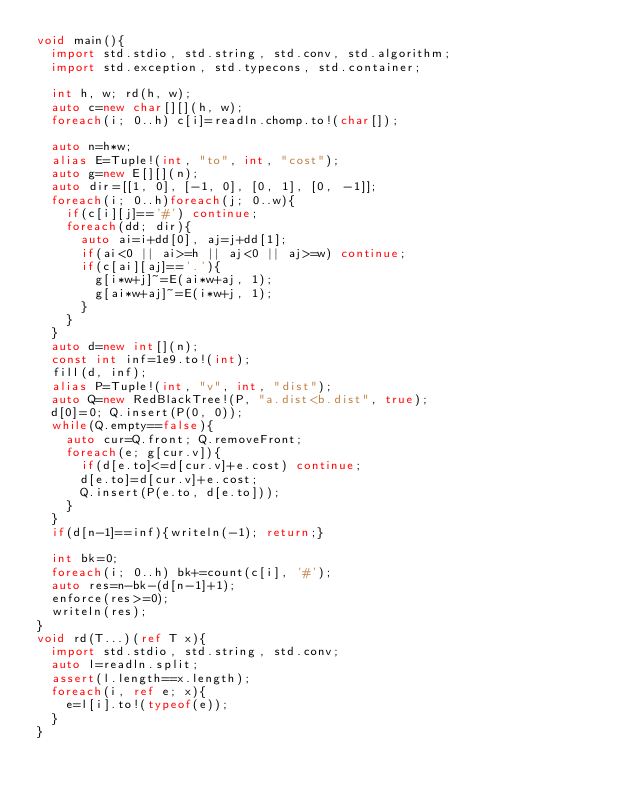Convert code to text. <code><loc_0><loc_0><loc_500><loc_500><_D_>void main(){
  import std.stdio, std.string, std.conv, std.algorithm;
  import std.exception, std.typecons, std.container;

  int h, w; rd(h, w);
  auto c=new char[][](h, w);
  foreach(i; 0..h) c[i]=readln.chomp.to!(char[]);

  auto n=h*w;
  alias E=Tuple!(int, "to", int, "cost");
  auto g=new E[][](n);
  auto dir=[[1, 0], [-1, 0], [0, 1], [0, -1]];
  foreach(i; 0..h)foreach(j; 0..w){
    if(c[i][j]=='#') continue;
    foreach(dd; dir){
      auto ai=i+dd[0], aj=j+dd[1];
      if(ai<0 || ai>=h || aj<0 || aj>=w) continue;
      if(c[ai][aj]=='.'){
        g[i*w+j]~=E(ai*w+aj, 1);
        g[ai*w+aj]~=E(i*w+j, 1);
      }
    }
  }
  auto d=new int[](n);
  const int inf=1e9.to!(int);
  fill(d, inf);
  alias P=Tuple!(int, "v", int, "dist");
  auto Q=new RedBlackTree!(P, "a.dist<b.dist", true);
  d[0]=0; Q.insert(P(0, 0));
  while(Q.empty==false){
    auto cur=Q.front; Q.removeFront;
    foreach(e; g[cur.v]){
      if(d[e.to]<=d[cur.v]+e.cost) continue;
      d[e.to]=d[cur.v]+e.cost;
      Q.insert(P(e.to, d[e.to]));
    }
  }
  if(d[n-1]==inf){writeln(-1); return;}

  int bk=0;
  foreach(i; 0..h) bk+=count(c[i], '#');
  auto res=n-bk-(d[n-1]+1);
  enforce(res>=0);
  writeln(res);
}
void rd(T...)(ref T x){
  import std.stdio, std.string, std.conv;
  auto l=readln.split;
  assert(l.length==x.length);
  foreach(i, ref e; x){
    e=l[i].to!(typeof(e));
  }
}</code> 